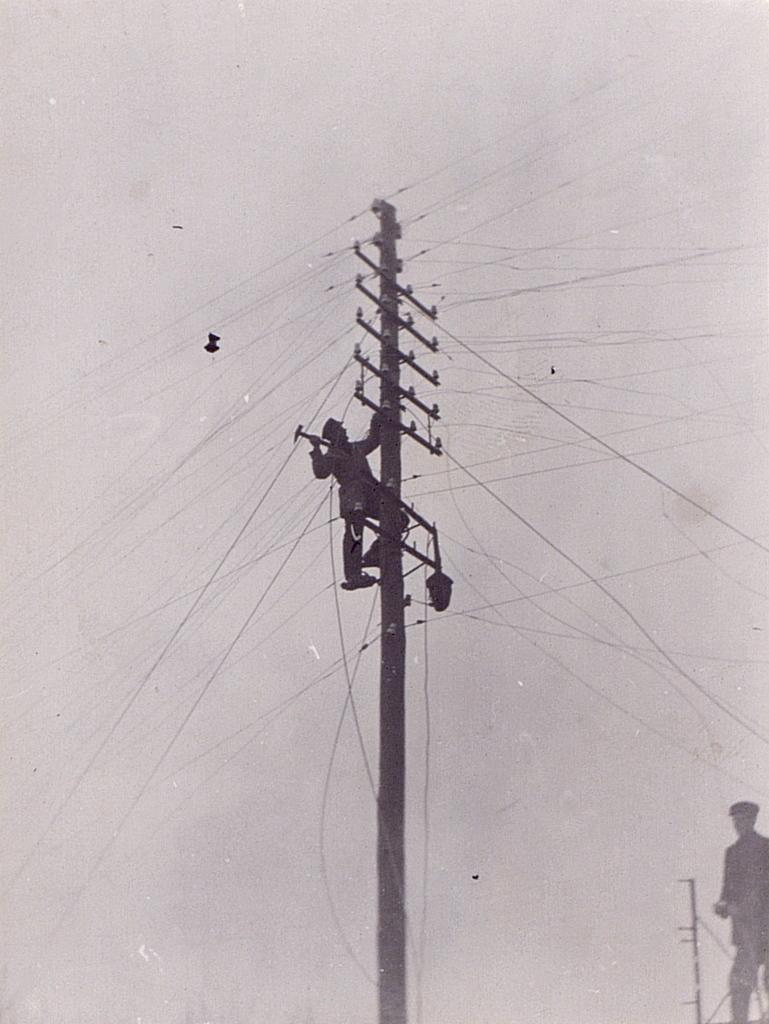How many people are in the image? There are two men in the image. What is one of the men doing in the image? One man is on a pole. What can be seen in the background of the image? The sky is visible in the background of the image. What is the overall appearance of the image? The image appears to be edited. What type of creature is hanging from the hook in the image? There is no hook or creature present in the image. 